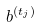<formula> <loc_0><loc_0><loc_500><loc_500>b ^ { ( t _ { j } ) }</formula> 